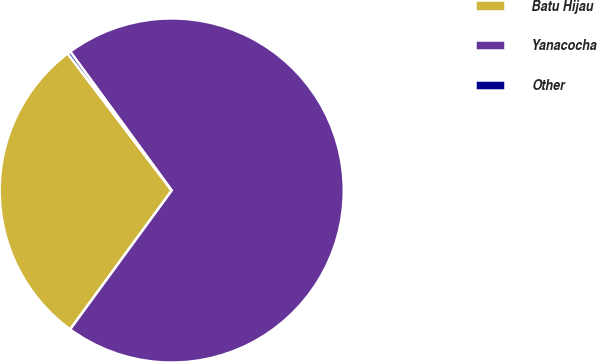Convert chart. <chart><loc_0><loc_0><loc_500><loc_500><pie_chart><fcel>Batu Hijau<fcel>Yanacocha<fcel>Other<nl><fcel>29.61%<fcel>70.09%<fcel>0.3%<nl></chart> 